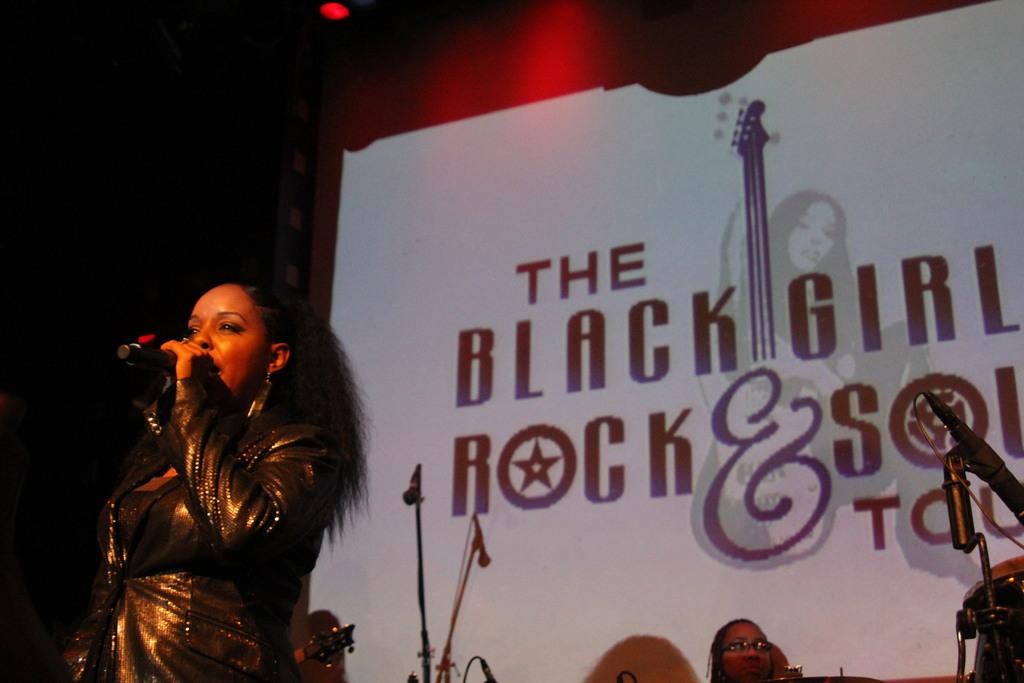What is the main subject of the image? There is a person (she) in the image. What is the person doing in the image? The person is standing and singing a song. What can be seen in the background of the image? There is a name poster in the background of the image. What type of cup is being used to express anger in the image? There is no cup or expression of anger present in the image. Can you tell me what animals are visible at the zoo in the image? There is no zoo or animals visible in the image; it features a person standing and singing a song with a name poster in the background. 